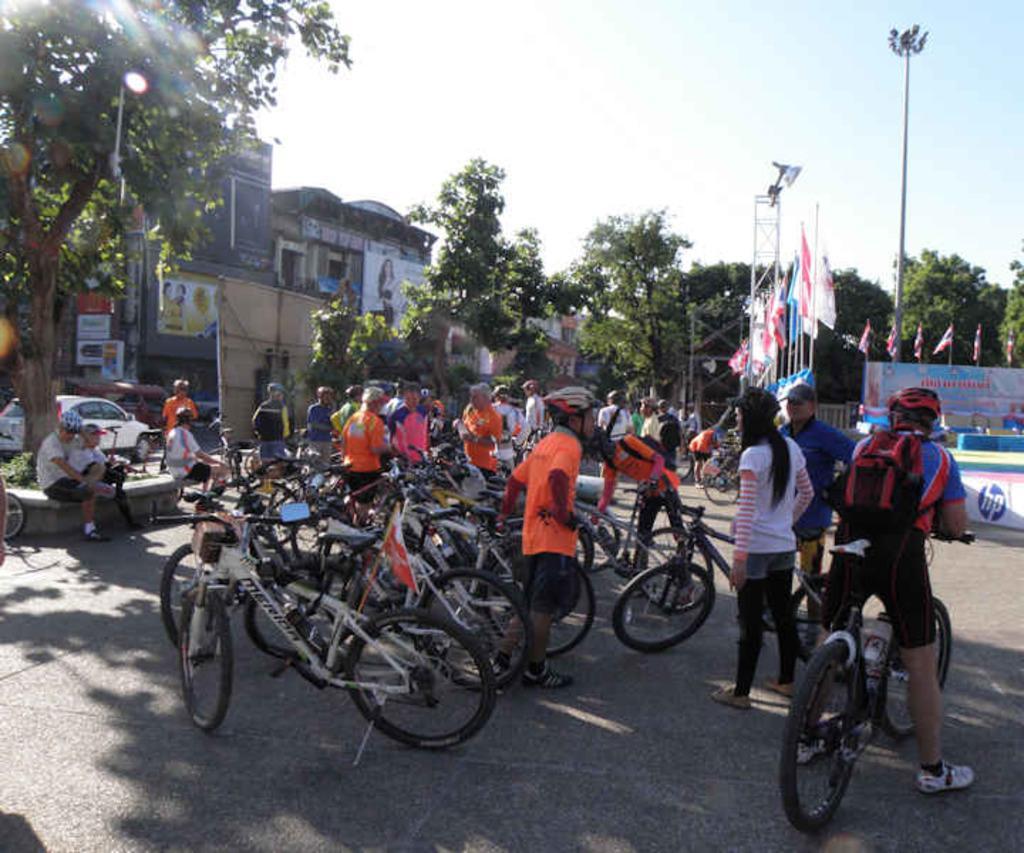Could you give a brief overview of what you see in this image? This image consists of many people wearing helmets. And there are bicycles parked on the road. At the bottom, there is a road. In the background, there are buildings along with trees. To the right, there are many flags. 